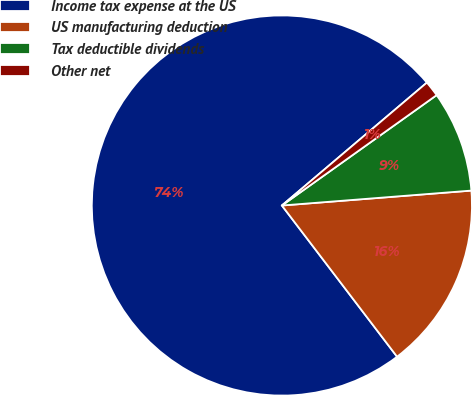Convert chart. <chart><loc_0><loc_0><loc_500><loc_500><pie_chart><fcel>Income tax expense at the US<fcel>US manufacturing deduction<fcel>Tax deductible dividends<fcel>Other net<nl><fcel>74.17%<fcel>15.89%<fcel>8.61%<fcel>1.33%<nl></chart> 